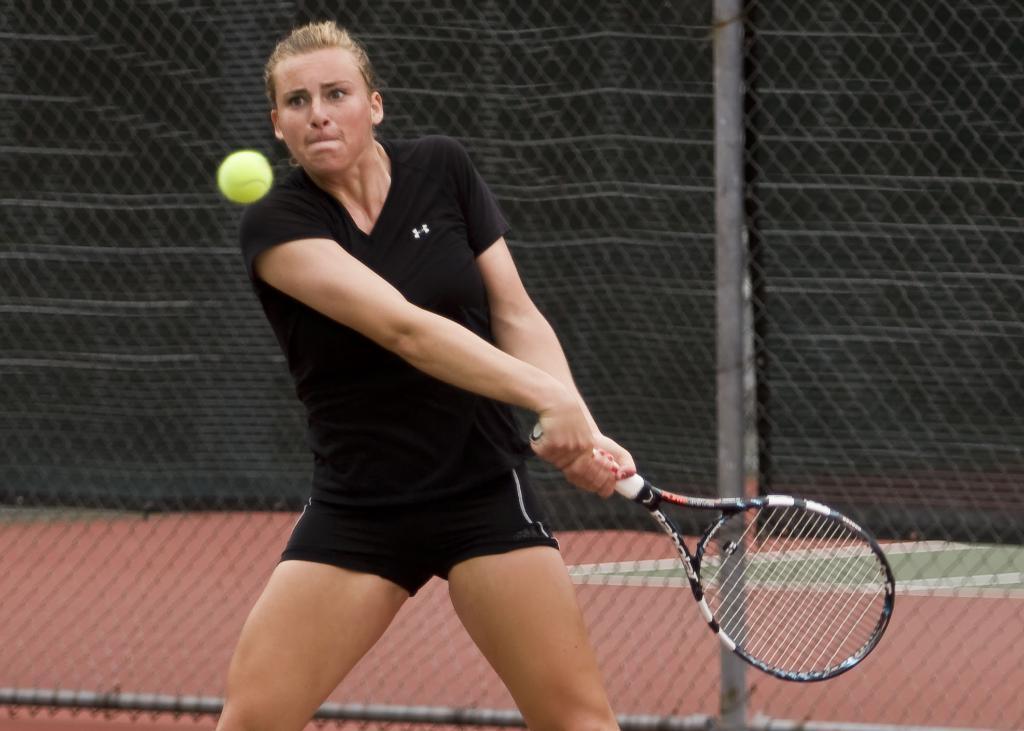How would you summarize this image in a sentence or two? In this image I can see a person playing badminton holding a bat which is in black color. I can also see a ball in green color. Background I can see a railing. 